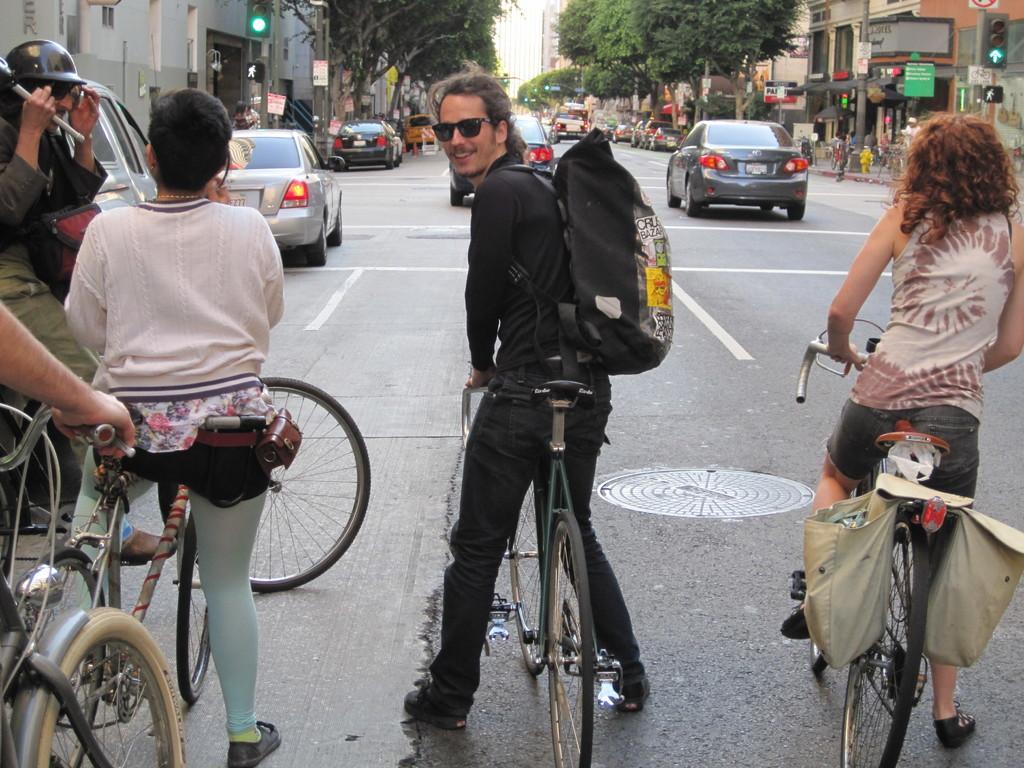Describe this image in one or two sentences. This picture describes about group of people, few people are standing with their bicycle in the road, in the background we can see traffic lights, hoarding, couple of cars and couple of trees. 